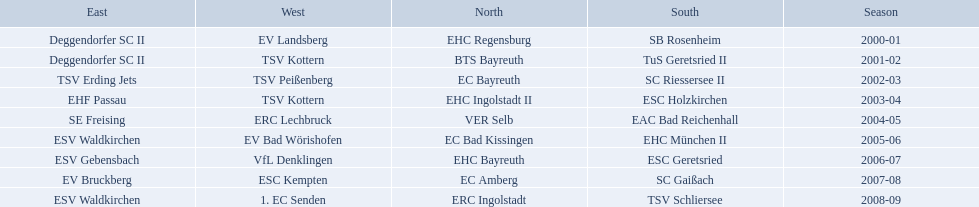Which teams played in the north? EHC Regensburg, BTS Bayreuth, EC Bayreuth, EHC Ingolstadt II, VER Selb, EC Bad Kissingen, EHC Bayreuth, EC Amberg, ERC Ingolstadt. Of these teams, which played during 2000-2001? EHC Regensburg. 